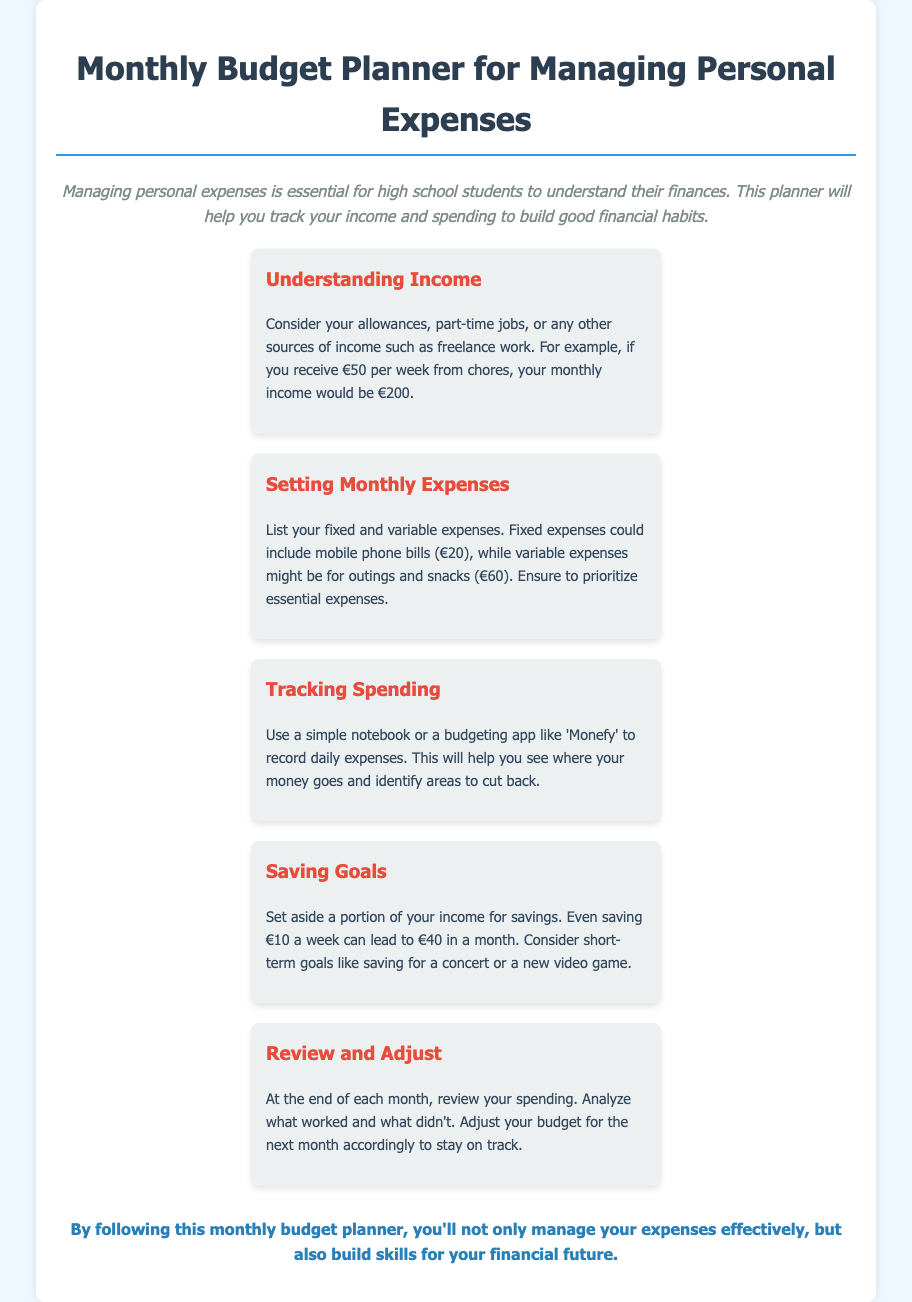What is the title of the document? The title of the document is presented at the top of the rendered page.
Answer: Monthly Budget Planner for Managing Personal Expenses What is advised for tracking spending? The document suggests using a notebook or a budgeting app to record daily expenses.
Answer: Notebook or budgeting app How much is a suggested weekly saving goal? The document discusses a weekly saving goal and provides an example of how much can be saved in a month.
Answer: €10 What is a fixed expense example mentioned? The document lists mobile phone bills as an example of a fixed expense.
Answer: Mobile phone bills What should be reviewed at the end of each month? The document emphasizes the importance of reviewing spending at the end of each month to analyze financial habits.
Answer: Spending What is the color of the text for headings in the menu items? The document states that headings have a specific color, which is noted in the styling section.
Answer: Red 